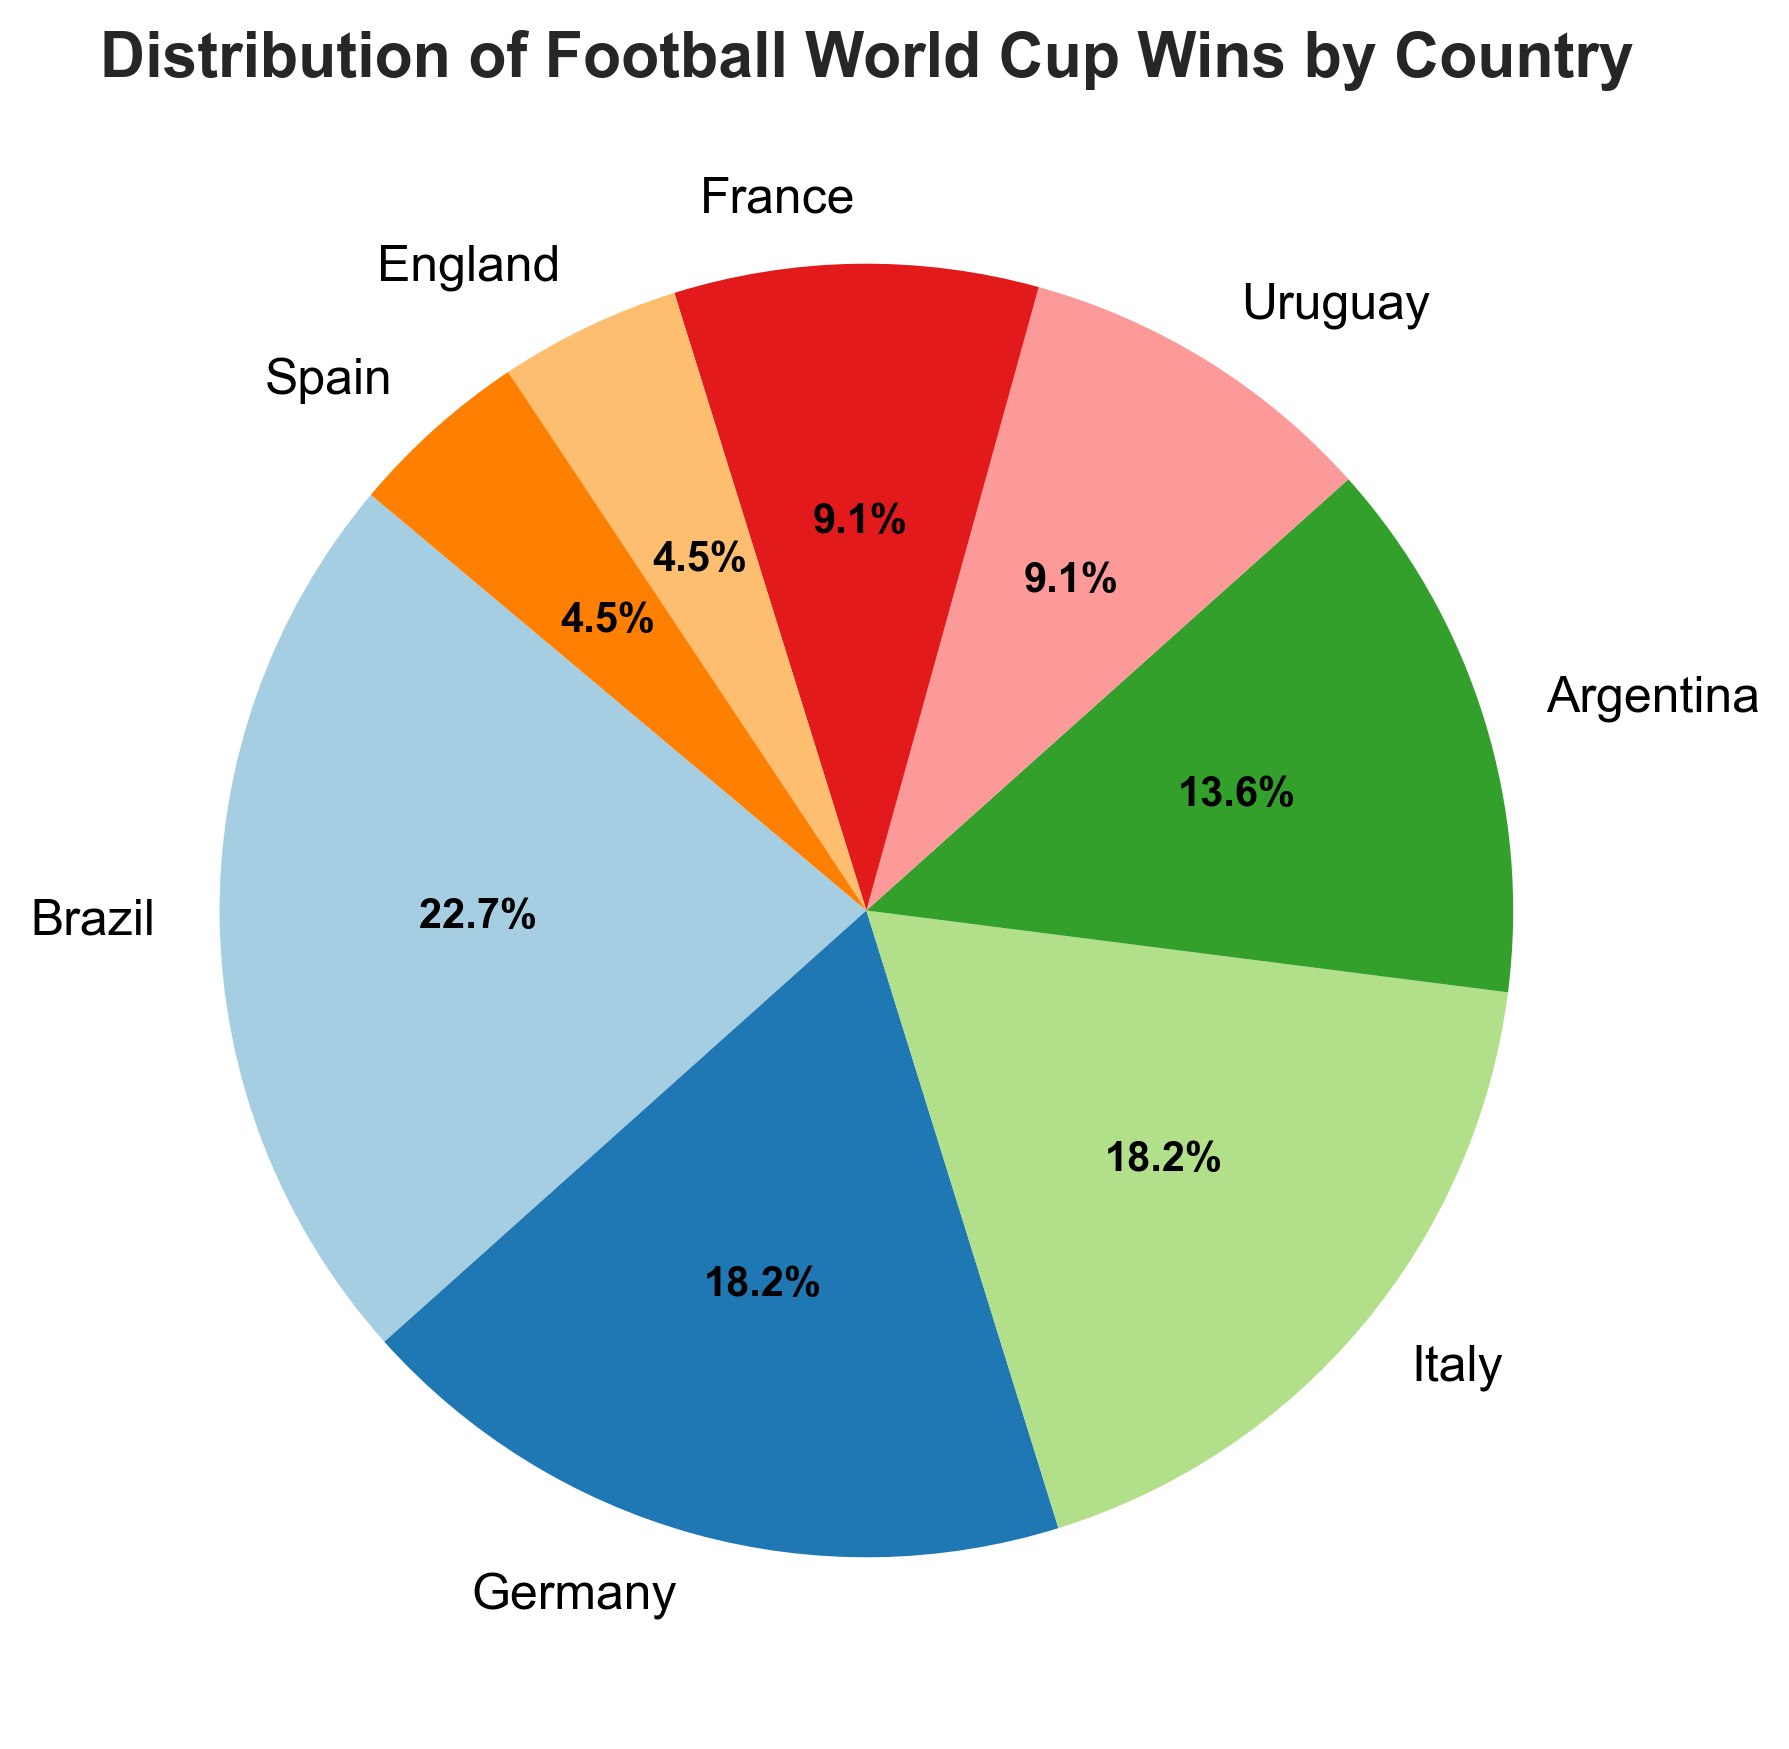Which country has the highest percentage of wins? The country with the highest percentage of wins is the one with the largest slice in the pie chart and Brazil has the largest slice with 5 wins, which is the highest.
Answer: Brazil How many countries have won more than 2 World Cups? By looking at the slices of the pie chart, we see that Brazil, Germany, and Italy have more than 2 World Cups each. Counting these, we get 3 countries.
Answer: 3 Which two countries have an equal number of World Cup wins? From the pie chart, we can see that Germany and Italy each have 4 wins, and Uruguay and France each have 2 wins.
Answer: Germany and Italy; Uruguay and France What is the combined percentage of wins by South American countries? The South American countries in the chart are Brazil (5 wins), Argentina (3 wins), and Uruguay (2 wins). The combined wins are 5 + 3 + 2 = 10 out of a total of 22 wins. Therefore, the combined percentage is (10/22) * 100 ≈ 45.5%.
Answer: 45.5% Which country has a greater number of wins, England or Spain? The pie chart shows that both England and Spain each have 1 win. Therefore, neither has a greater number of wins.
Answer: Neither What's the difference in the number of wins between the country with the most wins and the country with the least wins? Brazil has the most wins with 5, and both England and Spain have the least with 1 each. The difference between 5 and 1 is 4.
Answer: 4 Which countries have exactly 2 wins, and what is the total percentage these countries represent together? From the pie chart, Uruguay and France each have 2 wins. Hence, the total wins are 2 + 2 = 4. The total percentage is (4/22) * 100 ≈ 18.2%.
Answer: Uruguay and France, 18.2% What's the combined number of wins for European countries? The European countries in the chart are Germany (4 wins), Italy (4 wins), France (2 wins), England (1 win), and Spain (1 win). Adding these gives 4 + 4 + 2 + 1 + 1 = 12 wins.
Answer: 12 Which countries' segments are adjacent to each other in the pie chart? Based on the pie chart visualization, adjacent segments include Italy and Argentina, Uruguay and France, among others. Verification of these needs a visual view of the pie.
Answer: Italy and Argentina; Uruguay and France Is the percentage of wins for Brazil higher than the combined percentage of wins for Argentina and France? Brazil has 5 wins, while Argentina has 3 and France has 2, making a combination of 3 + 2 = 5 wins for Argentina and France. The percentage for Brazil is (5/22) * 100 ≈ 22.7%, and for Argentina and France together also ≈ 22.7%. Thus, neither percentage is higher than the other.
Answer: No 